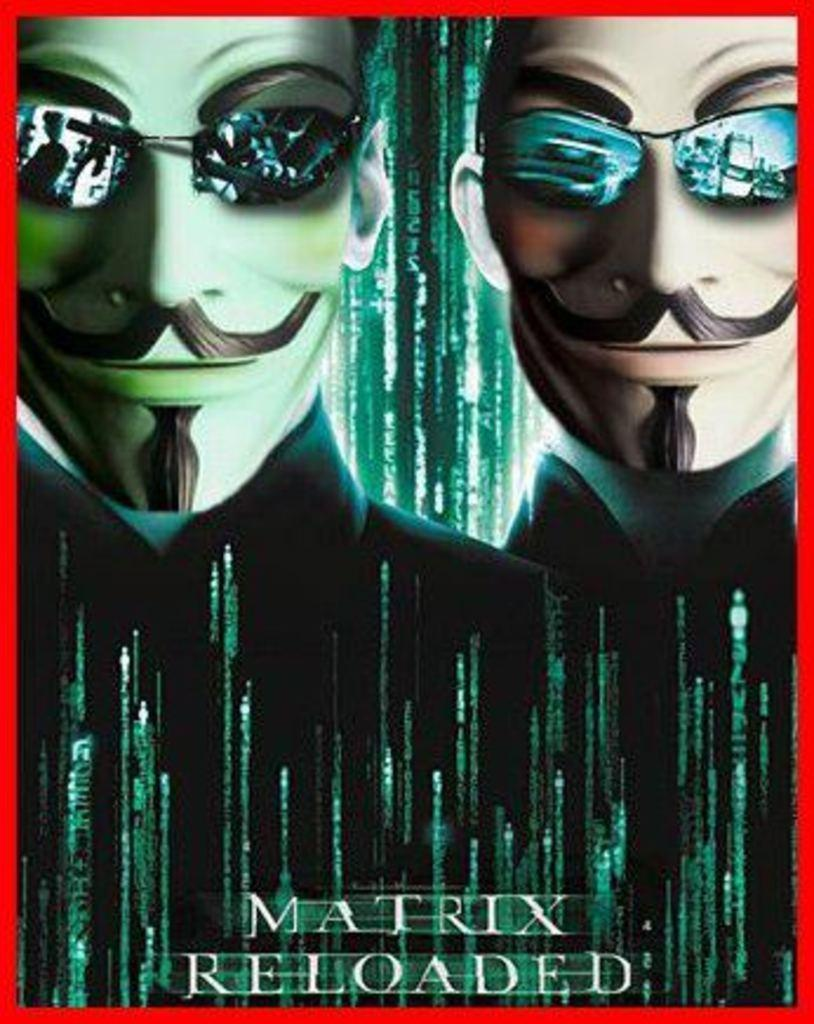What is the main object in the image? There is a poster in the image. What can be seen on the poster? The poster contains pictures of two men. Is there any text on the poster? Yes, there is text at the bottom of the poster. What color is the border of the poster? The poster border is red. Can you hear the whistle of the boat in the image? There is no whistle or boat present in the image; it only contains a poster with pictures of two men and text. 